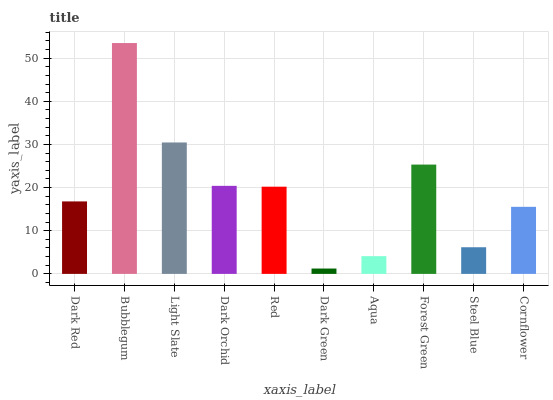Is Dark Green the minimum?
Answer yes or no. Yes. Is Bubblegum the maximum?
Answer yes or no. Yes. Is Light Slate the minimum?
Answer yes or no. No. Is Light Slate the maximum?
Answer yes or no. No. Is Bubblegum greater than Light Slate?
Answer yes or no. Yes. Is Light Slate less than Bubblegum?
Answer yes or no. Yes. Is Light Slate greater than Bubblegum?
Answer yes or no. No. Is Bubblegum less than Light Slate?
Answer yes or no. No. Is Red the high median?
Answer yes or no. Yes. Is Dark Red the low median?
Answer yes or no. Yes. Is Dark Red the high median?
Answer yes or no. No. Is Aqua the low median?
Answer yes or no. No. 